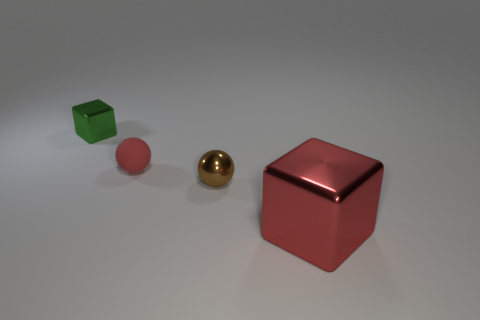Are there any other things that have the same material as the tiny red sphere?
Ensure brevity in your answer.  No. Is there a shiny object that has the same color as the tiny matte thing?
Provide a short and direct response. Yes. Are there an equal number of objects in front of the brown sphere and tiny metal objects in front of the green shiny object?
Offer a terse response. Yes. Is the shape of the brown metallic thing the same as the red object behind the brown thing?
Give a very brief answer. Yes. How many other things are the same material as the green thing?
Your response must be concise. 2. There is a big red metallic object; are there any metal objects behind it?
Provide a short and direct response. Yes. There is a brown sphere; does it have the same size as the block in front of the red rubber object?
Ensure brevity in your answer.  No. There is a block that is on the right side of the sphere that is in front of the tiny matte thing; what color is it?
Ensure brevity in your answer.  Red. Is the green metallic object the same size as the red shiny thing?
Offer a terse response. No. There is a metal thing that is both behind the big shiny cube and in front of the small red rubber thing; what is its color?
Provide a short and direct response. Brown. 